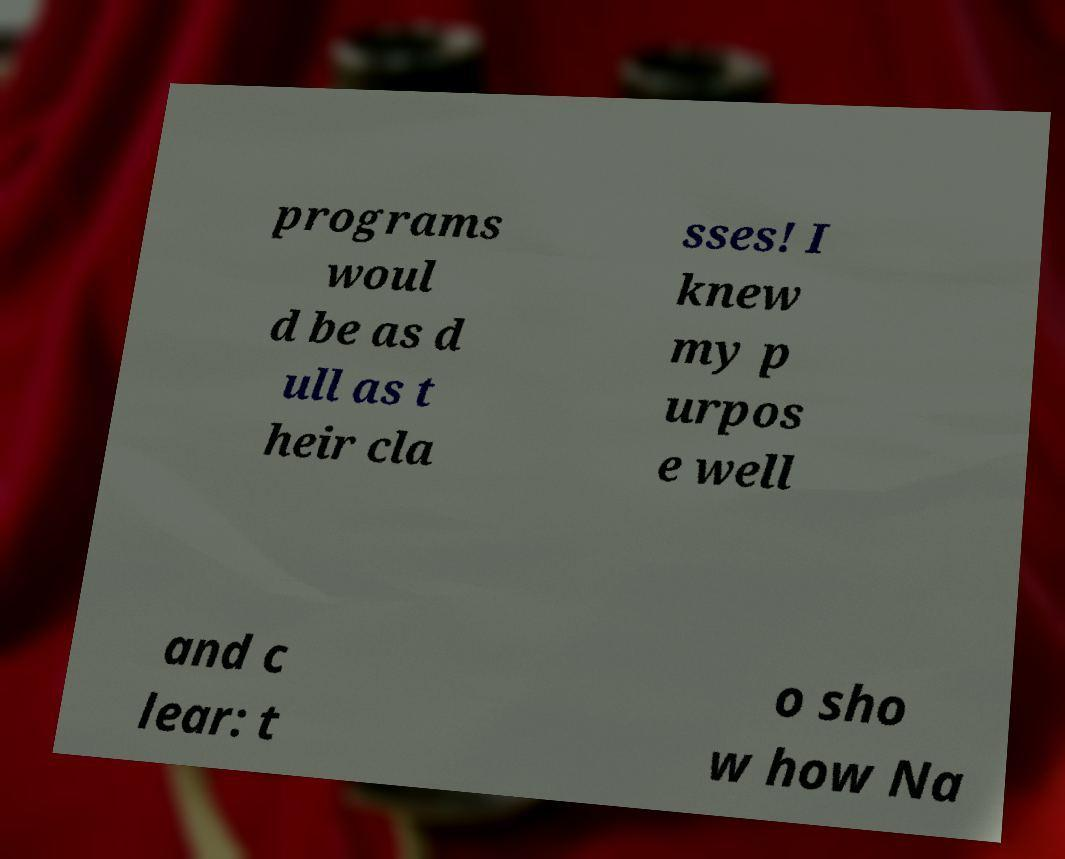Could you extract and type out the text from this image? programs woul d be as d ull as t heir cla sses! I knew my p urpos e well and c lear: t o sho w how Na 